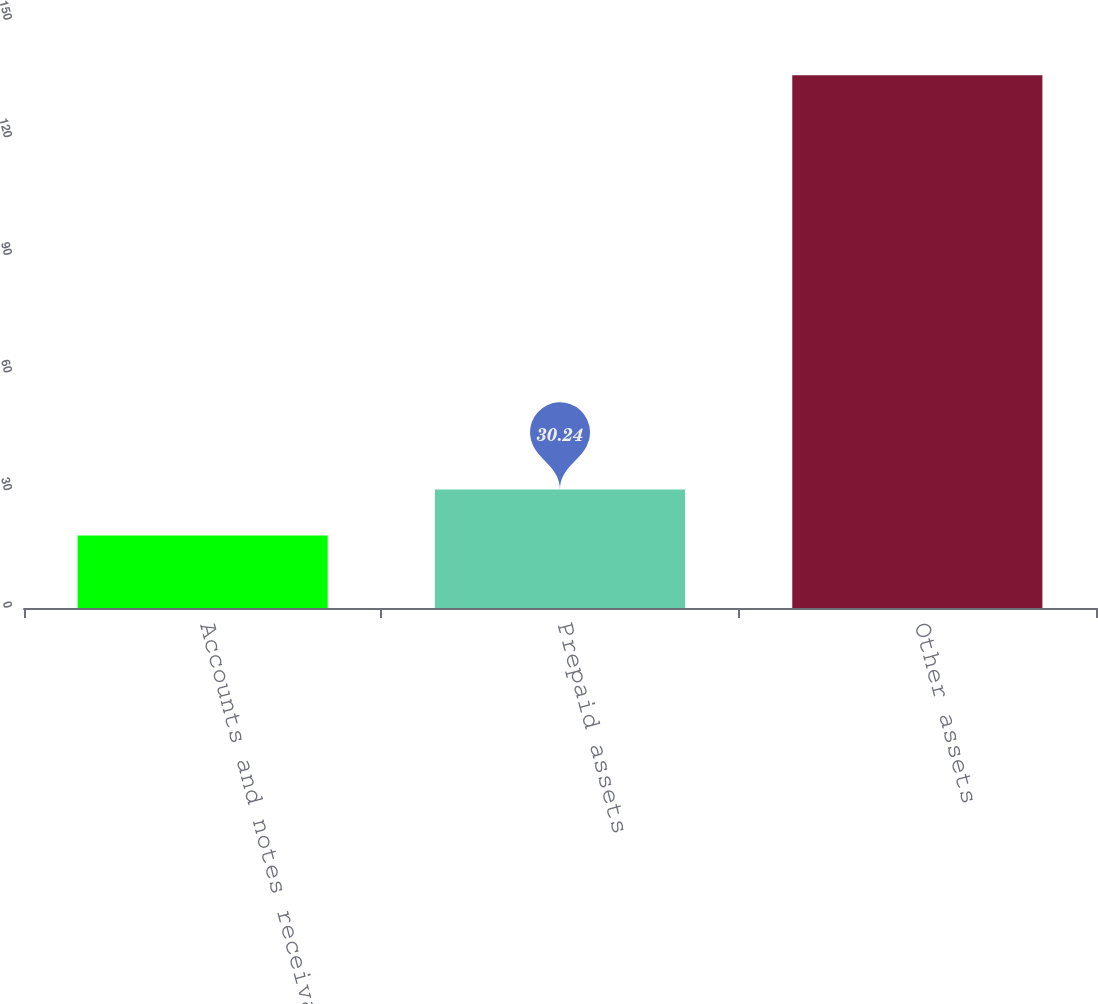Convert chart. <chart><loc_0><loc_0><loc_500><loc_500><bar_chart><fcel>Accounts and notes receivable<fcel>Prepaid assets<fcel>Other assets<nl><fcel>18.5<fcel>30.24<fcel>135.9<nl></chart> 